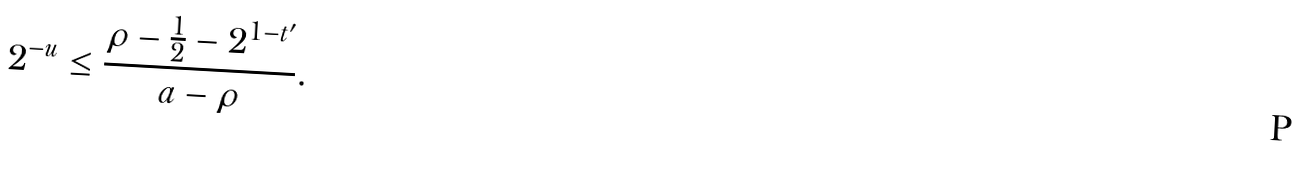<formula> <loc_0><loc_0><loc_500><loc_500>2 ^ { - u } \leq \frac { \rho - \frac { 1 } { 2 } - 2 ^ { 1 - t ^ { \prime } } } { a - \rho } .</formula> 